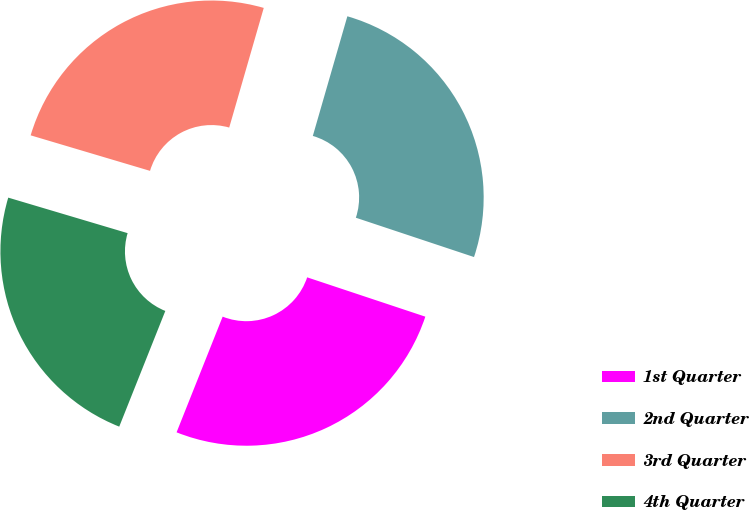Convert chart to OTSL. <chart><loc_0><loc_0><loc_500><loc_500><pie_chart><fcel>1st Quarter<fcel>2nd Quarter<fcel>3rd Quarter<fcel>4th Quarter<nl><fcel>25.92%<fcel>25.64%<fcel>24.87%<fcel>23.57%<nl></chart> 